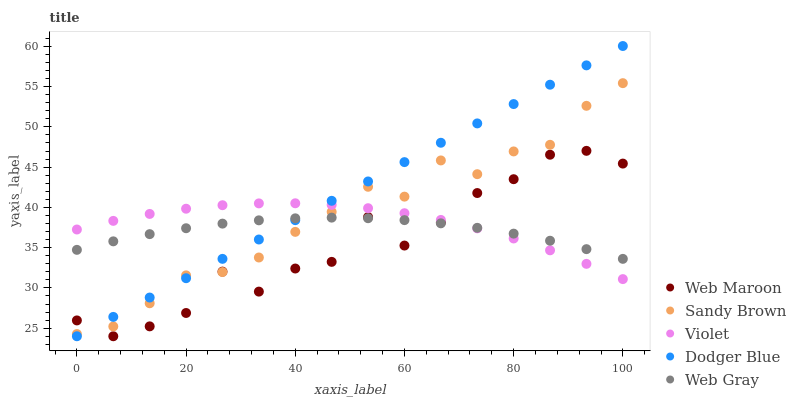Does Web Maroon have the minimum area under the curve?
Answer yes or no. Yes. Does Dodger Blue have the maximum area under the curve?
Answer yes or no. Yes. Does Web Gray have the minimum area under the curve?
Answer yes or no. No. Does Web Gray have the maximum area under the curve?
Answer yes or no. No. Is Dodger Blue the smoothest?
Answer yes or no. Yes. Is Web Maroon the roughest?
Answer yes or no. Yes. Is Web Gray the smoothest?
Answer yes or no. No. Is Web Gray the roughest?
Answer yes or no. No. Does Web Maroon have the lowest value?
Answer yes or no. Yes. Does Web Gray have the lowest value?
Answer yes or no. No. Does Dodger Blue have the highest value?
Answer yes or no. Yes. Does Web Maroon have the highest value?
Answer yes or no. No. Does Web Maroon intersect Violet?
Answer yes or no. Yes. Is Web Maroon less than Violet?
Answer yes or no. No. Is Web Maroon greater than Violet?
Answer yes or no. No. 